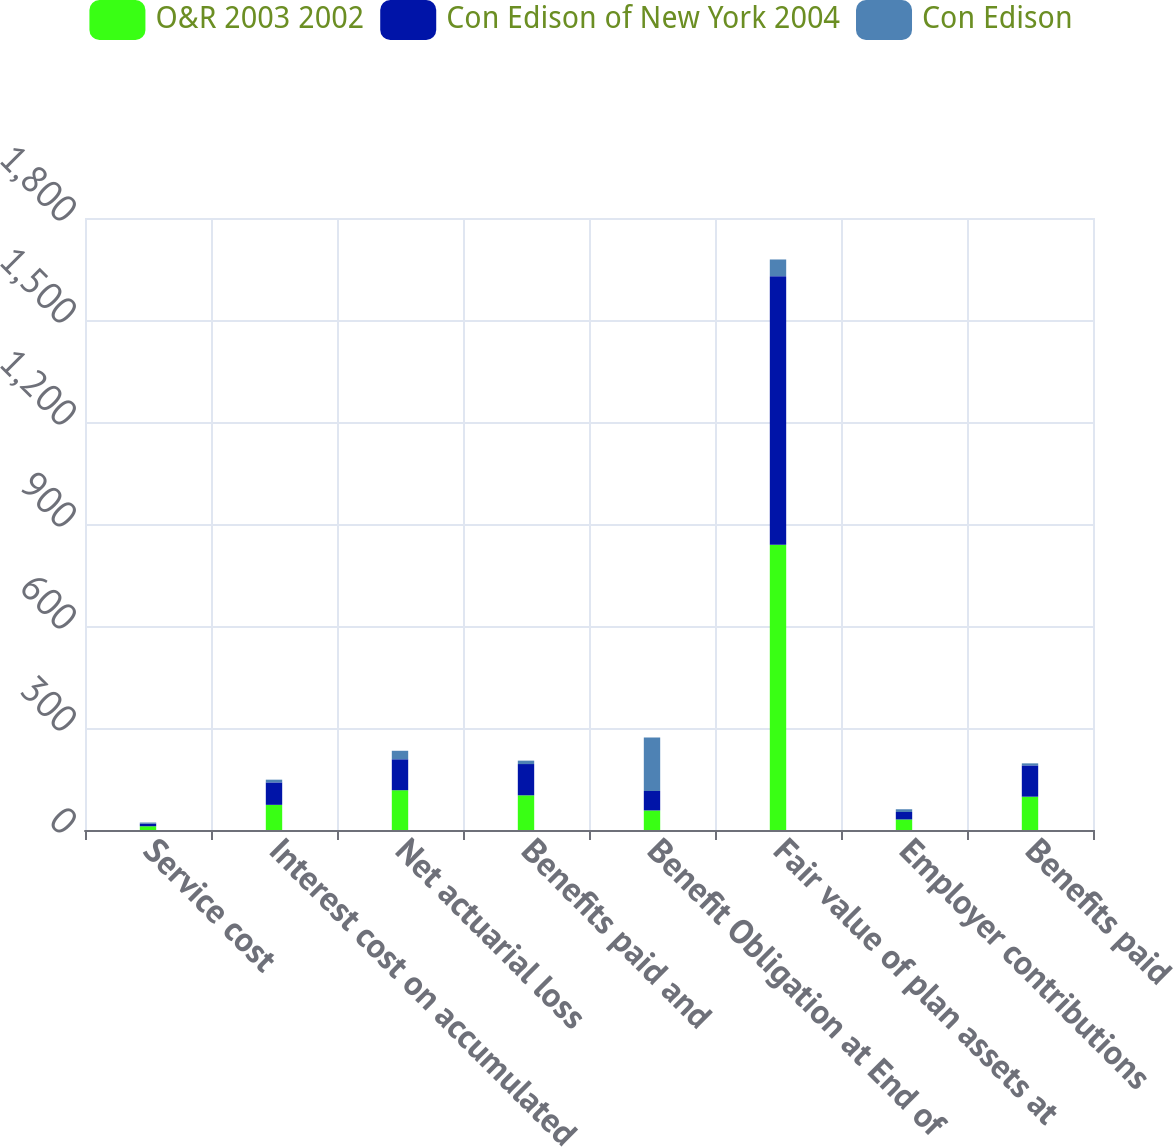<chart> <loc_0><loc_0><loc_500><loc_500><stacked_bar_chart><ecel><fcel>Service cost<fcel>Interest cost on accumulated<fcel>Net actuarial loss<fcel>Benefits paid and<fcel>Benefit Obligation at End of<fcel>Fair value of plan assets at<fcel>Employer contributions<fcel>Benefits paid<nl><fcel>O&R 2003 2002<fcel>11<fcel>74<fcel>117<fcel>102<fcel>57.5<fcel>839<fcel>31<fcel>98<nl><fcel>Con Edison of New York 2004<fcel>8<fcel>66<fcel>91<fcel>92<fcel>57.5<fcel>790<fcel>22<fcel>92<nl><fcel>Con Edison<fcel>3<fcel>8<fcel>25<fcel>10<fcel>157<fcel>49<fcel>8<fcel>6<nl></chart> 